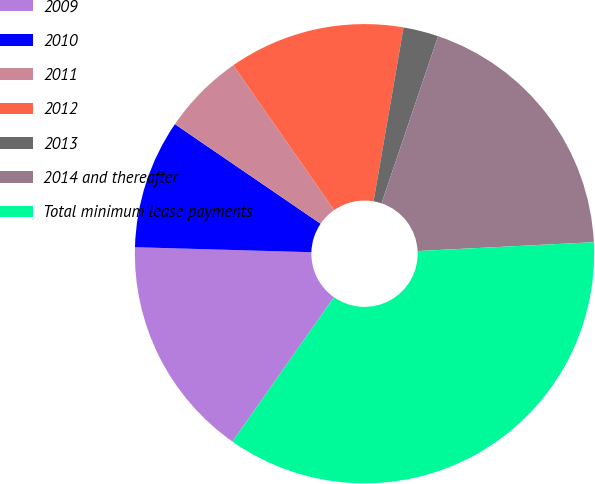Convert chart to OTSL. <chart><loc_0><loc_0><loc_500><loc_500><pie_chart><fcel>2009<fcel>2010<fcel>2011<fcel>2012<fcel>2013<fcel>2014 and thereafter<fcel>Total minimum lease payments<nl><fcel>15.7%<fcel>9.09%<fcel>5.78%<fcel>12.4%<fcel>2.47%<fcel>19.01%<fcel>35.55%<nl></chart> 